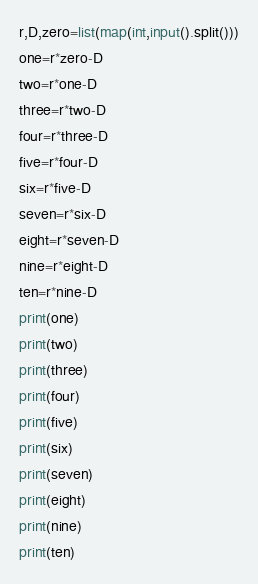Convert code to text. <code><loc_0><loc_0><loc_500><loc_500><_Python_>r,D,zero=list(map(int,input().split()))
one=r*zero-D
two=r*one-D
three=r*two-D
four=r*three-D
five=r*four-D
six=r*five-D
seven=r*six-D
eight=r*seven-D
nine=r*eight-D
ten=r*nine-D
print(one)
print(two)
print(three)
print(four)
print(five)
print(six)
print(seven)
print(eight)
print(nine)
print(ten)
</code> 